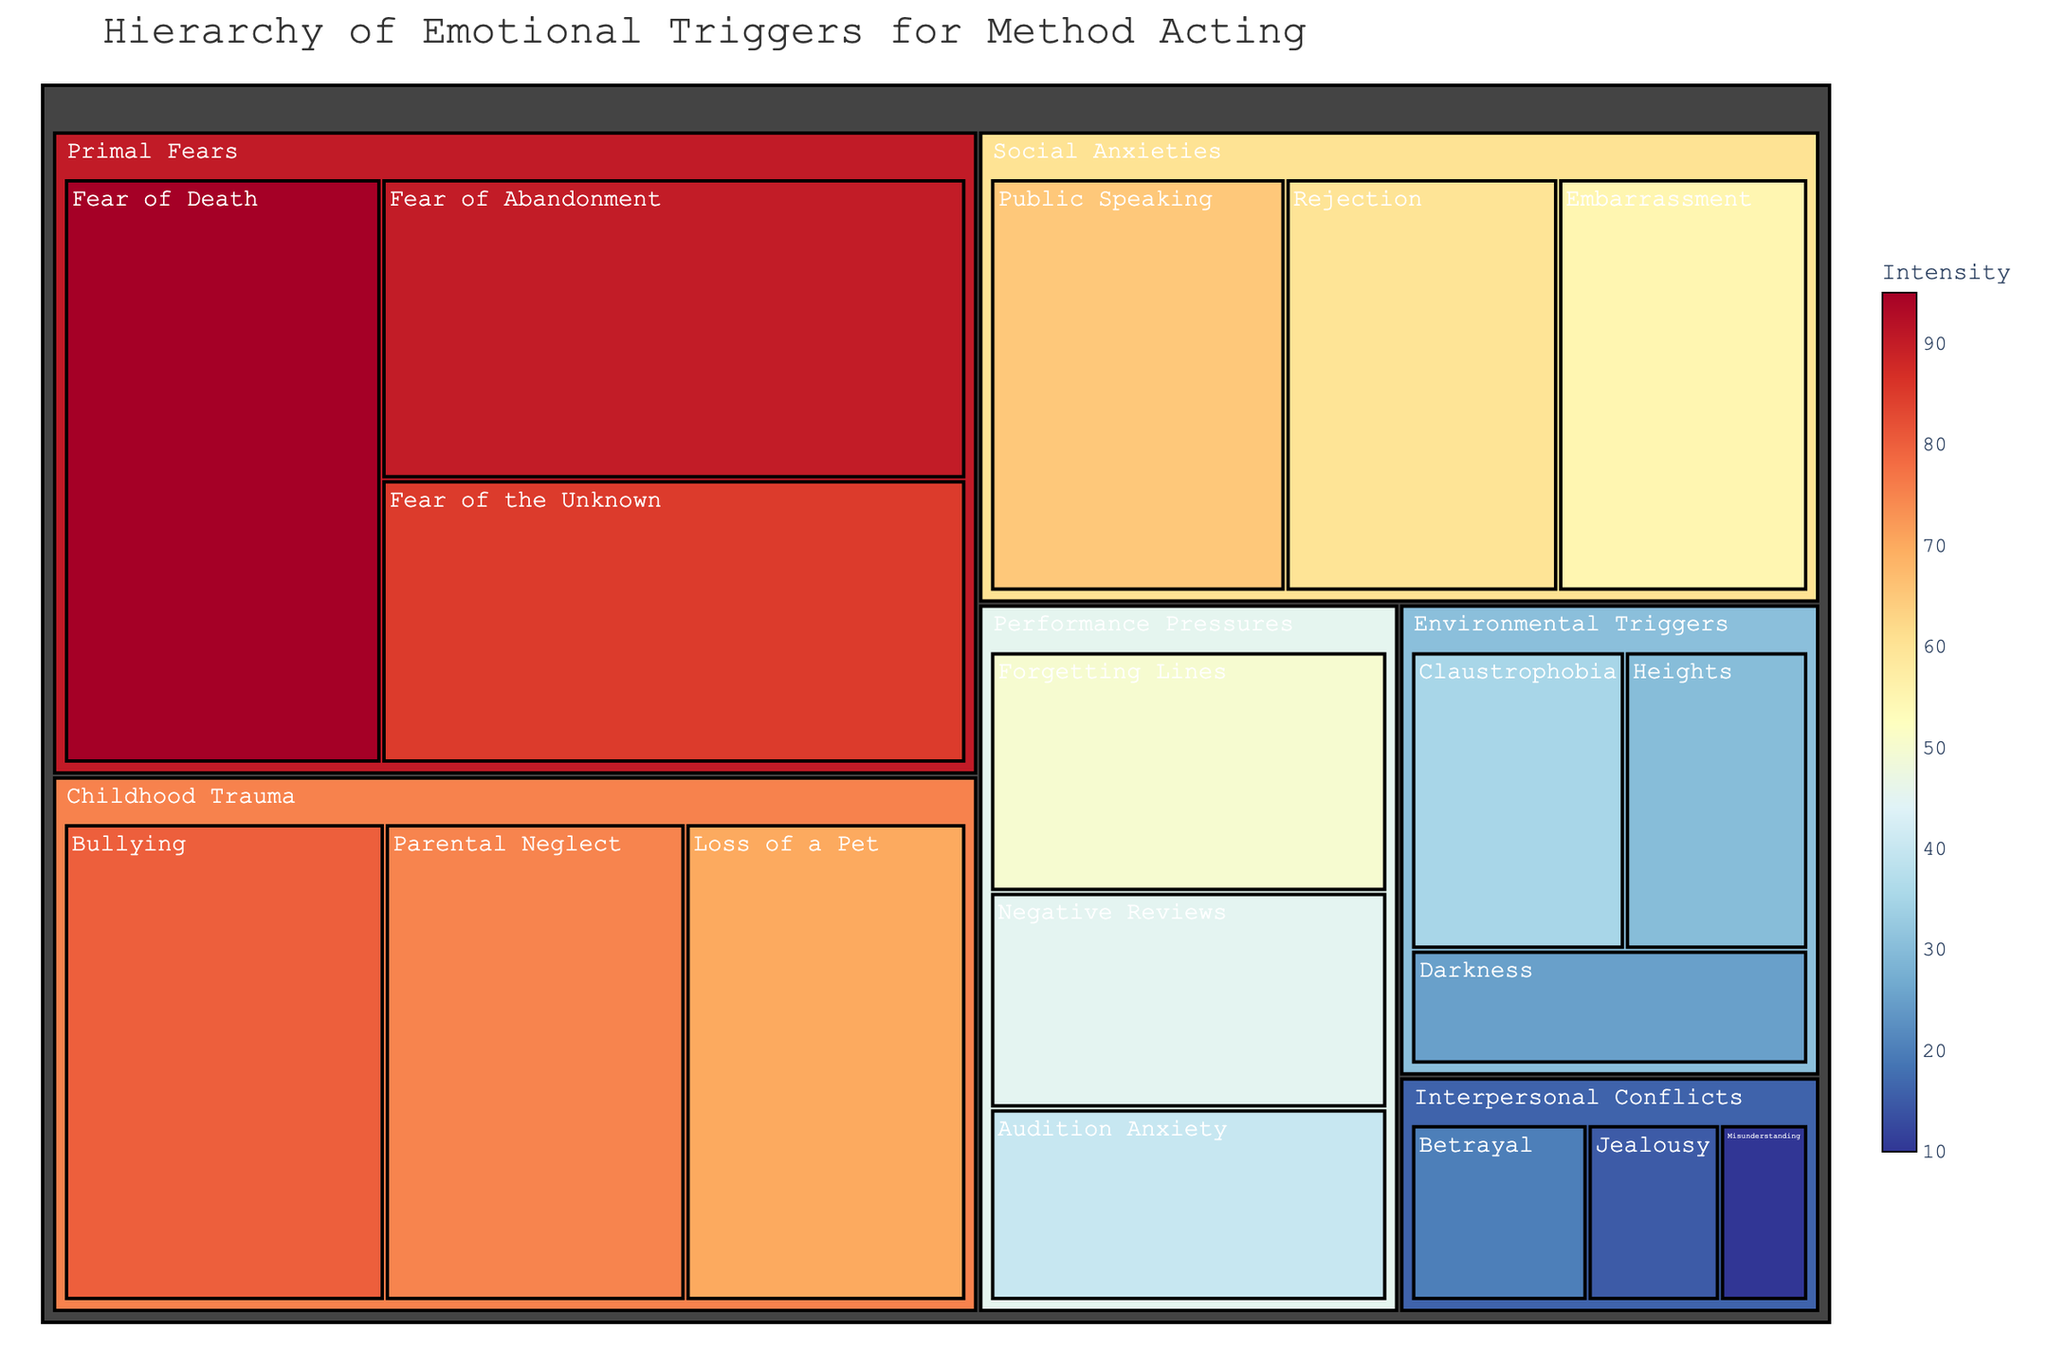What is the title of the treemap? The title is typically displayed at the top of a treemap. Reading it directly from the figure reveals the title.
Answer: Hierarchy of Emotional Triggers for Method Acting How many primary categories of emotional triggers are there in the treemap? The primary categories are  "Primal Fears," "Childhood Trauma," "Social Anxieties," "Performance Pressures," "Environmental Triggers," and "Interpersonal Conflicts." Counting these categories gives the result.
Answer: 6 Which subcategory within the "Primal Fears" category has the highest intensity level? Look at the subcategories within "Primal Fears" and find the one with the highest intensity number. Here, "Fear of Death" has an intensity of 95, which is the highest in this category.
Answer: Fear of Death Compare the intensity of "Public Speaking" and "Forgetting Lines." Which one is higher? Locate both "Public Speaking" under "Social Anxieties" and "Forgetting Lines" under "Performance Pressures" and compare their intensity values. Public Speaking has an intensity of 65, and Forgetting Lines has an intensity of 50, so Public Speaking is higher.
Answer: Public Speaking What is the average intensity of subcategories within "Performance Pressures"? The subcategories are "Forgetting Lines" with an intensity of 50, "Negative Reviews" with 45, and "Audition Anxiety" with 40. Summing these (50 + 45 + 40) gives 135. Dividing by the number of subcategories (3) results in 135 / 3 = 45.
Answer: 45 Which category has the least intense emotional trigger? Look for the subcategory with the lowest intensity value across all categories. "Misunderstanding" under "Interpersonal Conflicts" has the lowest intensity of 10.
Answer: Interpersonal Conflicts Rank the subcategories in "Childhood Trauma" from highest to lowest intensity. Identify the subcategories under "Childhood Trauma" and their intensities, then arrange them in descending order. "Bullying" (80), "Parental Neglect" (75), and "Loss of a Pet" (70).
Answer: Bullying, Parental Neglect, Loss of a Pet Calculate the total intensity for all subcategories under "Environmental Triggers." Sum the intensities of "Claustrophobia" (35), "Heights" (30), and "Darkness" (25). Total intensity is 35 + 30 + 25 = 90.
Answer: 90 Which subcategory under "Social Anxieties" has the closest intensity to "Heights" under "Environmental Triggers"? The intensity for "Heights" is 30. Under "Social Anxieties," compare "Public Speaking" (65), "Rejection" (60), and "Embarrassment" (55) to find the closest value. "Embarrassment" at 55 is the closest to 30.
Answer: Embarrassment In which category is the subcategory "Fear of Abandonment," and what is its intensity? Locate "Fear of Abandonment" in the treemap. It is under "Primal Fears" with an intensity value provided directly.
Answer: Primal Fears, 90 